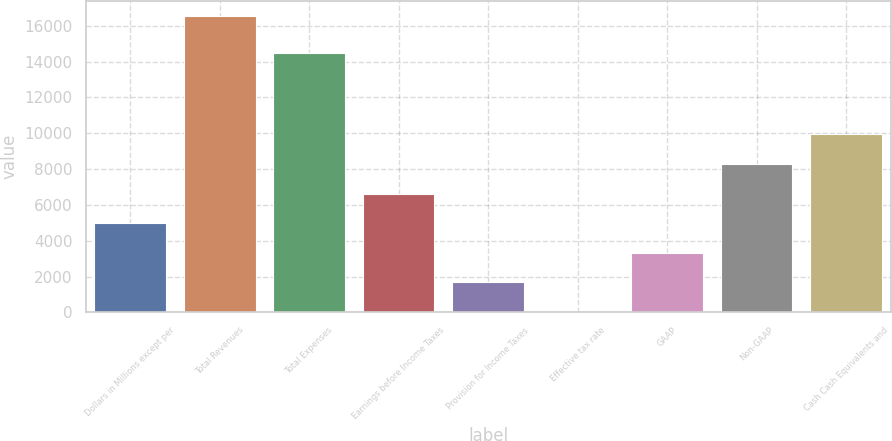Convert chart. <chart><loc_0><loc_0><loc_500><loc_500><bar_chart><fcel>Dollars in Millions except per<fcel>Total Revenues<fcel>Total Expenses<fcel>Earnings before Income Taxes<fcel>Provision for Income Taxes<fcel>Effective tax rate<fcel>GAAP<fcel>Non-GAAP<fcel>Cash Cash Equivalents and<nl><fcel>4983.05<fcel>16560<fcel>14483<fcel>6636.9<fcel>1675.35<fcel>21.5<fcel>3329.2<fcel>8290.75<fcel>9944.6<nl></chart> 